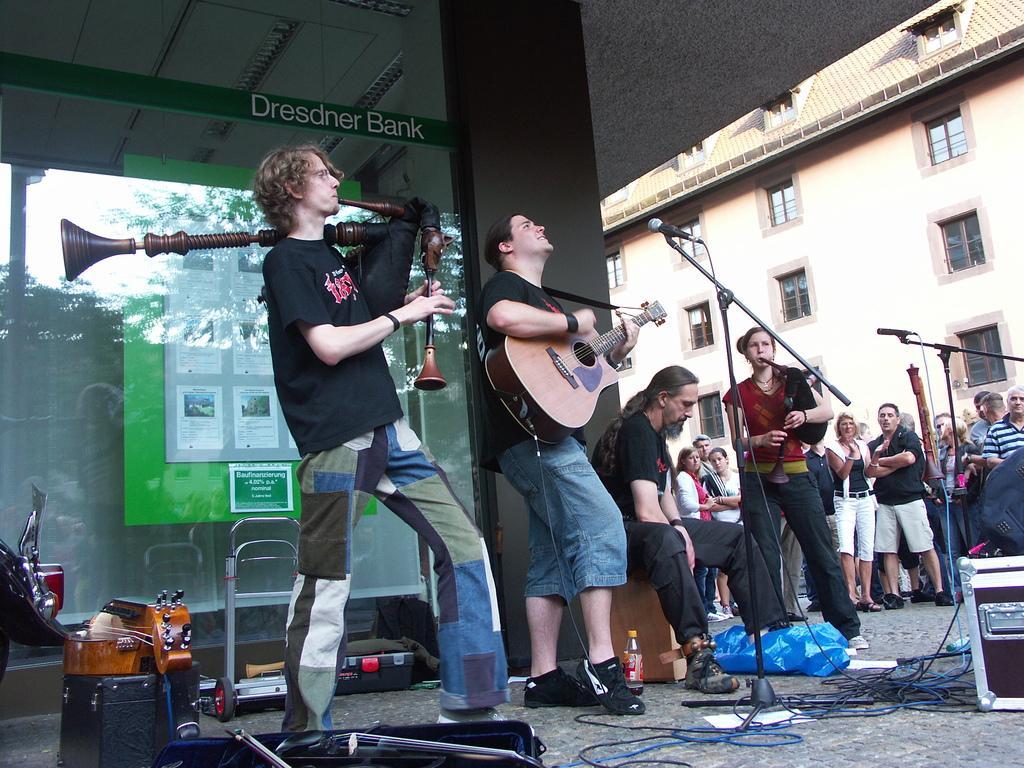How would you summarize this image in a sentence or two? In the center of the image, few peoples are playing a musical instrument. On right side, group of peoples are standing and there is a building in the background. On left side, we can see a glass window, banner, boards, rod. 